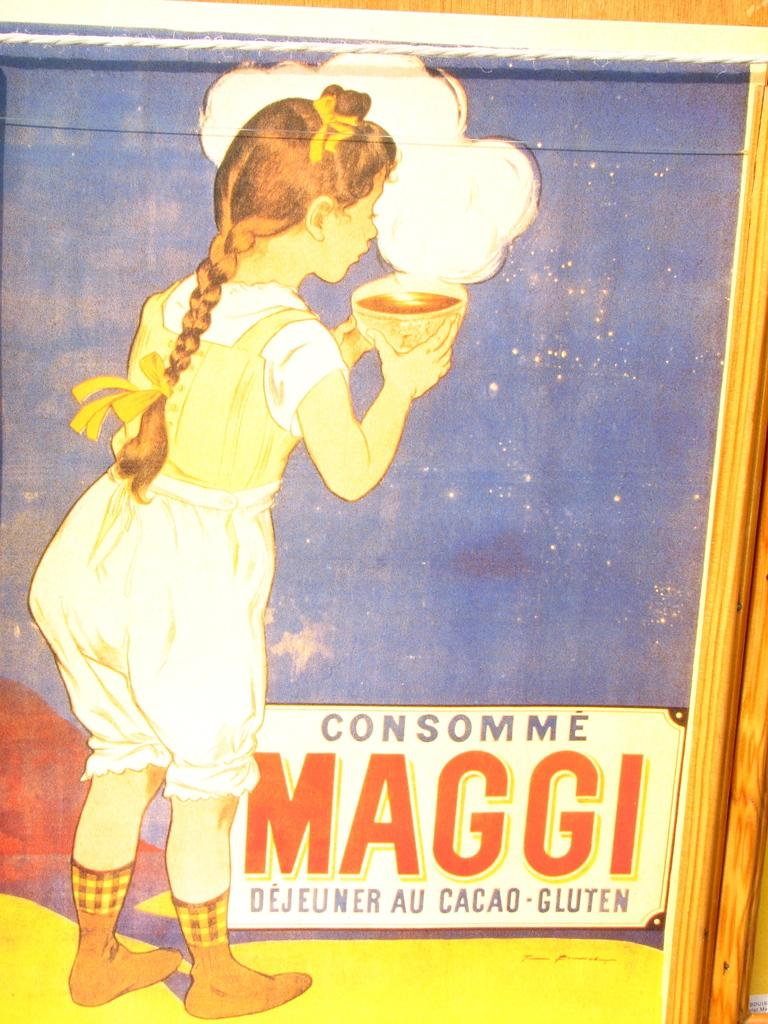What object is present in the image that typically holds a photograph? There is a photo frame in the image. What can be seen inside the photo frame? The photo frame contains an image of a girl. What is the girl holding in the image? The girl is holding a bowl in the image. What is located below the girl in the image? There is a board below the girl in the image. Is the girl wearing a crown in the image? There is no mention of a crown in the image, so it cannot be determined if the girl is wearing one. 